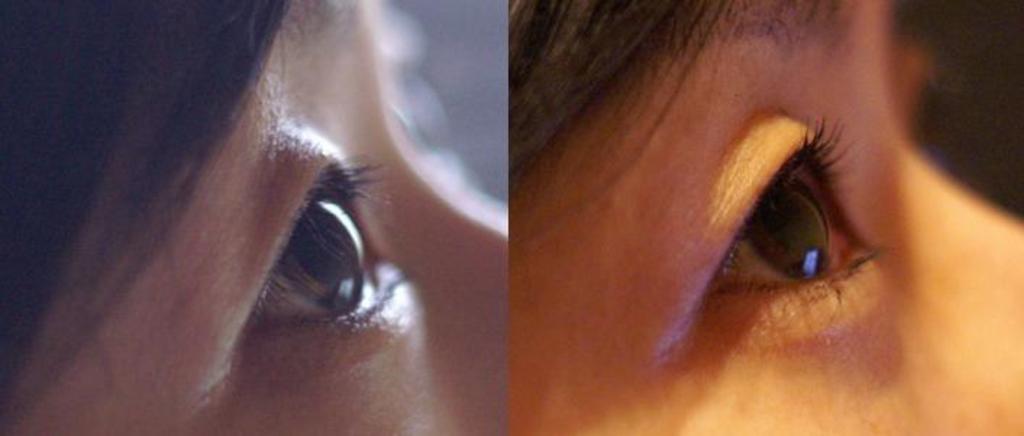Can you describe this image briefly? This picture is a collage of two images. One image is looking dim and the other image is bright. Both the images are eyes of a woman. 